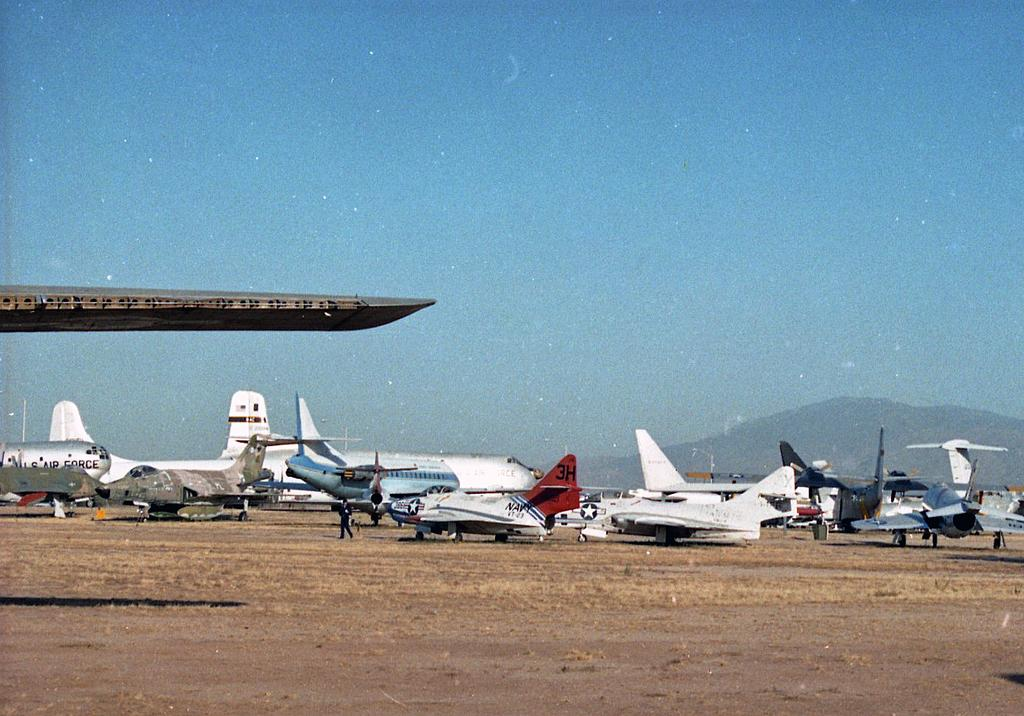What is the main subject of the image? The main subject of the image is aeroplanes. Where are the aeroplanes located in the image? The aeroplanes are at the bottom side of the image. What else can be seen in the image besides the aeroplanes? There is sky visible in the image. Where is the sky located in the image? The sky is at the top side of the image. What type of key is used to unlock the beast in the image? There is no key or beast present in the image; it only features aeroplanes and sky. What is the stem of the plant in the image? There is no plant or stem present in the image. 